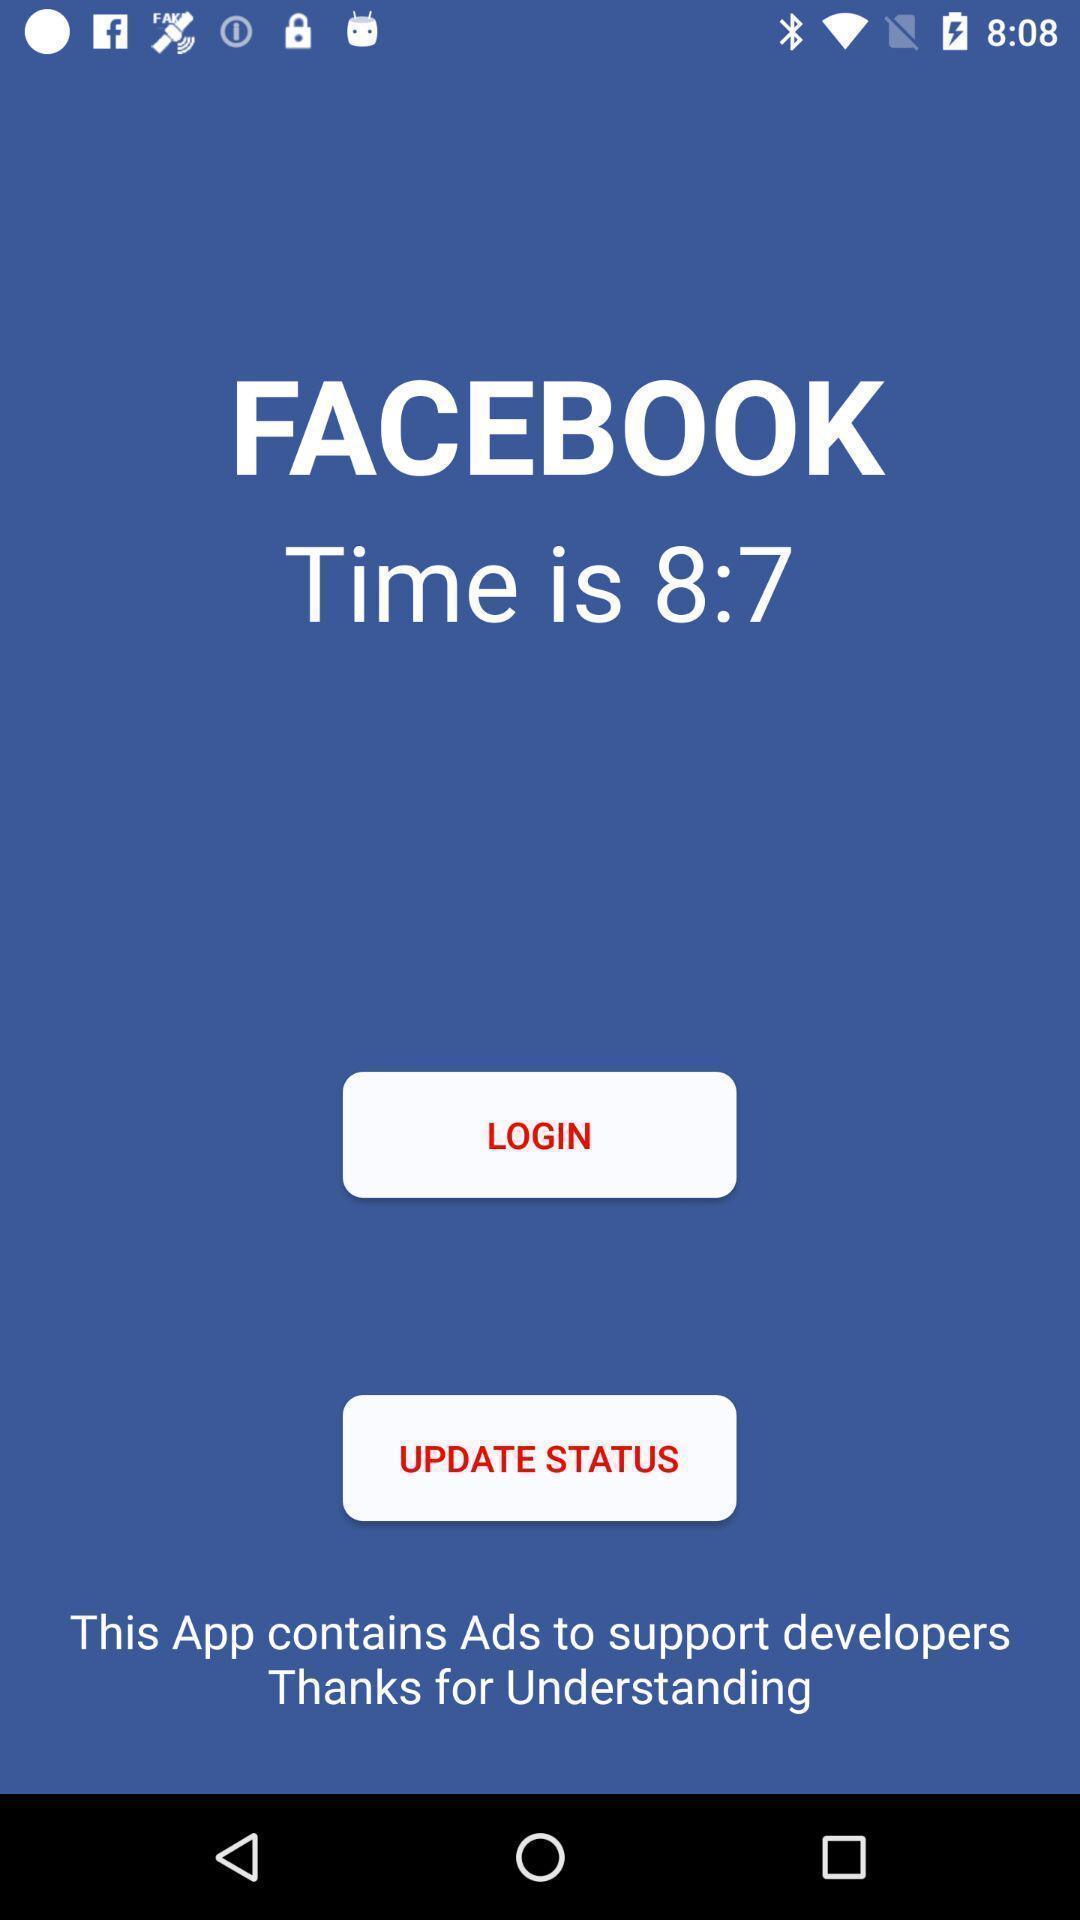Please provide a description for this image. Login page of a social media app. 